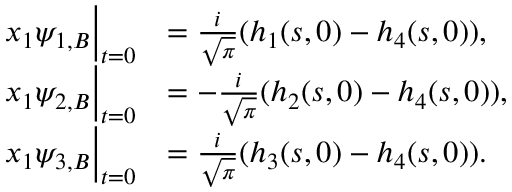<formula> <loc_0><loc_0><loc_500><loc_500>\begin{array} { r l } { x _ { 1 } \psi _ { 1 , B } \Big | _ { t = 0 } } & { = \frac { i } { \sqrt { \pi } } ( h _ { 1 } ( s , 0 ) - h _ { 4 } ( s , 0 ) ) , } \\ { x _ { 1 } \psi _ { 2 , B } \Big | _ { t = 0 } } & { = - \frac { i } { \sqrt { \pi } } ( h _ { 2 } ( s , 0 ) - h _ { 4 } ( s , 0 ) ) , } \\ { x _ { 1 } \psi _ { 3 , B } \Big | _ { t = 0 } } & { = \frac { i } { \sqrt { \pi } } ( h _ { 3 } ( s , 0 ) - h _ { 4 } ( s , 0 ) ) . } \end{array}</formula> 